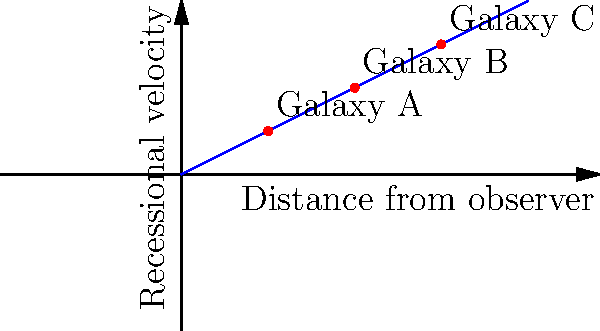The diagram shows the relationship between the distance of galaxies from an observer and their recessional velocities. What does this linear relationship represent in the context of the expanding universe, and how does it relate to Hubble's Law? To understand this diagram and its relation to the expanding universe, let's break it down step-by-step:

1. The x-axis represents the distance of galaxies from the observer, while the y-axis represents their recessional velocities (the speed at which they appear to be moving away).

2. We can see that the relationship between distance and recessional velocity is linear, forming a straight line.

3. This linear relationship is a key feature of Hubble's Law, which states that the recessional velocity of a galaxy is directly proportional to its distance from the observer.

4. Mathematically, Hubble's Law is expressed as:

   $$ v = H_0 \cdot d $$

   Where $v$ is the recessional velocity, $d$ is the distance, and $H_0$ is the Hubble constant.

5. The slope of the line in the diagram represents the Hubble constant ($H_0$), which is a measure of the current expansion rate of the universe.

6. This relationship is evidence for the expansion of the universe. As we look at galaxies farther away from us, they appear to be moving away faster, creating a uniform expansion pattern.

7. It's important to note that this expansion is not the movement of galaxies through space, but rather the expansion of space itself, carrying the galaxies along with it.

8. This concept aligns with the Big Bang theory, suggesting that the universe began from a single point and has been expanding ever since.

The linear relationship in this diagram, therefore, represents the uniform expansion of the universe as described by Hubble's Law, providing crucial evidence for our understanding of cosmic evolution and structure.
Answer: Hubble's Law, indicating uniform cosmic expansion 